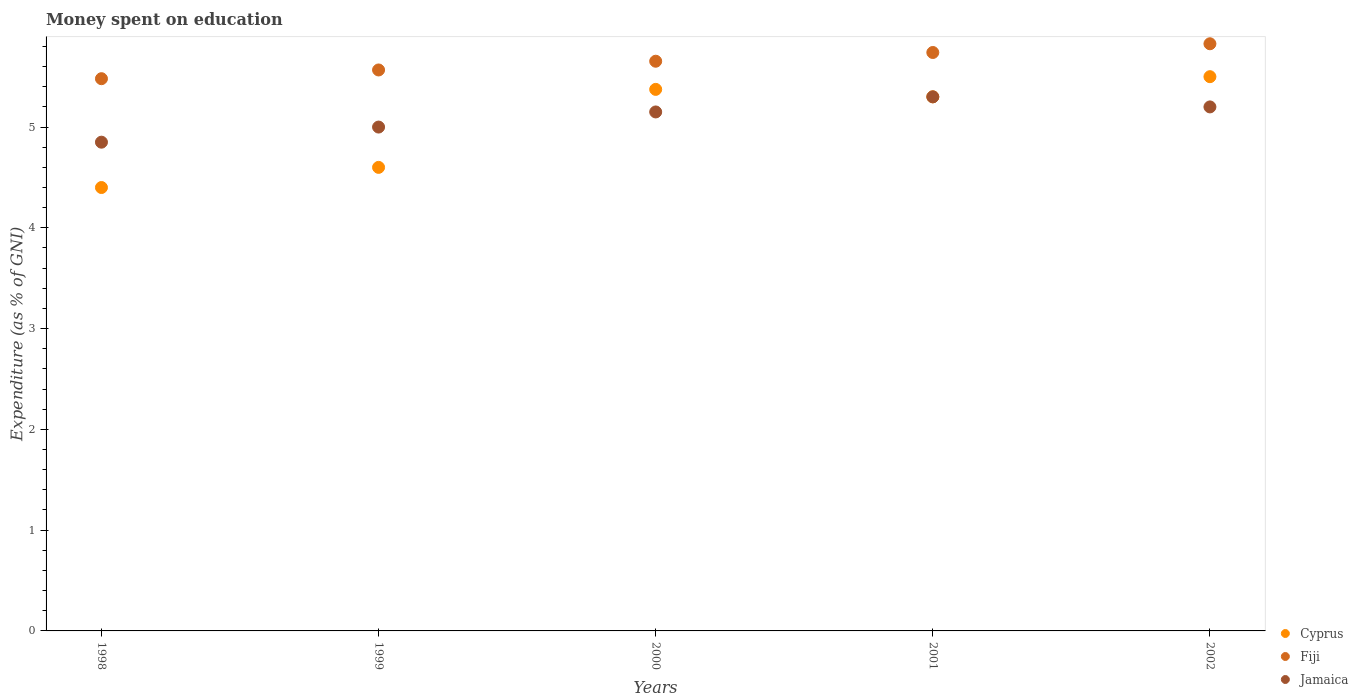Is the number of dotlines equal to the number of legend labels?
Your answer should be very brief. Yes. What is the amount of money spent on education in Fiji in 2002?
Make the answer very short. 5.83. Across all years, what is the maximum amount of money spent on education in Fiji?
Give a very brief answer. 5.83. Across all years, what is the minimum amount of money spent on education in Fiji?
Give a very brief answer. 5.48. In which year was the amount of money spent on education in Jamaica maximum?
Your answer should be compact. 2001. What is the total amount of money spent on education in Cyprus in the graph?
Offer a terse response. 25.17. What is the difference between the amount of money spent on education in Cyprus in 1998 and that in 2002?
Keep it short and to the point. -1.1. What is the difference between the amount of money spent on education in Cyprus in 1998 and the amount of money spent on education in Jamaica in 1999?
Offer a terse response. -0.6. What is the average amount of money spent on education in Fiji per year?
Your answer should be compact. 5.65. In the year 1999, what is the difference between the amount of money spent on education in Cyprus and amount of money spent on education in Fiji?
Your response must be concise. -0.97. In how many years, is the amount of money spent on education in Fiji greater than 1.6 %?
Ensure brevity in your answer.  5. What is the ratio of the amount of money spent on education in Cyprus in 1998 to that in 1999?
Keep it short and to the point. 0.96. Is the difference between the amount of money spent on education in Cyprus in 2001 and 2002 greater than the difference between the amount of money spent on education in Fiji in 2001 and 2002?
Provide a short and direct response. No. What is the difference between the highest and the second highest amount of money spent on education in Cyprus?
Provide a short and direct response. 0.13. What is the difference between the highest and the lowest amount of money spent on education in Fiji?
Ensure brevity in your answer.  0.35. In how many years, is the amount of money spent on education in Fiji greater than the average amount of money spent on education in Fiji taken over all years?
Offer a very short reply. 2. Is the sum of the amount of money spent on education in Cyprus in 1998 and 2001 greater than the maximum amount of money spent on education in Jamaica across all years?
Your response must be concise. Yes. Is the amount of money spent on education in Fiji strictly greater than the amount of money spent on education in Cyprus over the years?
Your response must be concise. Yes. Is the amount of money spent on education in Cyprus strictly less than the amount of money spent on education in Jamaica over the years?
Your answer should be compact. No. How many dotlines are there?
Your answer should be very brief. 3. How many years are there in the graph?
Offer a terse response. 5. Are the values on the major ticks of Y-axis written in scientific E-notation?
Ensure brevity in your answer.  No. Does the graph contain any zero values?
Ensure brevity in your answer.  No. Does the graph contain grids?
Keep it short and to the point. No. Where does the legend appear in the graph?
Make the answer very short. Bottom right. What is the title of the graph?
Offer a terse response. Money spent on education. What is the label or title of the X-axis?
Keep it short and to the point. Years. What is the label or title of the Y-axis?
Your answer should be compact. Expenditure (as % of GNI). What is the Expenditure (as % of GNI) in Cyprus in 1998?
Keep it short and to the point. 4.4. What is the Expenditure (as % of GNI) of Fiji in 1998?
Your response must be concise. 5.48. What is the Expenditure (as % of GNI) of Jamaica in 1998?
Ensure brevity in your answer.  4.85. What is the Expenditure (as % of GNI) in Fiji in 1999?
Your answer should be compact. 5.57. What is the Expenditure (as % of GNI) of Jamaica in 1999?
Offer a terse response. 5. What is the Expenditure (as % of GNI) in Cyprus in 2000?
Ensure brevity in your answer.  5.37. What is the Expenditure (as % of GNI) in Fiji in 2000?
Give a very brief answer. 5.65. What is the Expenditure (as % of GNI) of Jamaica in 2000?
Your answer should be very brief. 5.15. What is the Expenditure (as % of GNI) in Fiji in 2001?
Provide a short and direct response. 5.74. What is the Expenditure (as % of GNI) in Jamaica in 2001?
Ensure brevity in your answer.  5.3. What is the Expenditure (as % of GNI) of Cyprus in 2002?
Provide a succinct answer. 5.5. What is the Expenditure (as % of GNI) in Fiji in 2002?
Offer a very short reply. 5.83. Across all years, what is the maximum Expenditure (as % of GNI) of Cyprus?
Provide a short and direct response. 5.5. Across all years, what is the maximum Expenditure (as % of GNI) of Fiji?
Your answer should be compact. 5.83. Across all years, what is the maximum Expenditure (as % of GNI) of Jamaica?
Offer a very short reply. 5.3. Across all years, what is the minimum Expenditure (as % of GNI) of Cyprus?
Make the answer very short. 4.4. Across all years, what is the minimum Expenditure (as % of GNI) in Fiji?
Make the answer very short. 5.48. Across all years, what is the minimum Expenditure (as % of GNI) in Jamaica?
Ensure brevity in your answer.  4.85. What is the total Expenditure (as % of GNI) in Cyprus in the graph?
Make the answer very short. 25.17. What is the total Expenditure (as % of GNI) of Fiji in the graph?
Your answer should be very brief. 28.27. What is the total Expenditure (as % of GNI) of Jamaica in the graph?
Your answer should be very brief. 25.5. What is the difference between the Expenditure (as % of GNI) of Fiji in 1998 and that in 1999?
Ensure brevity in your answer.  -0.09. What is the difference between the Expenditure (as % of GNI) of Jamaica in 1998 and that in 1999?
Provide a short and direct response. -0.15. What is the difference between the Expenditure (as % of GNI) of Cyprus in 1998 and that in 2000?
Give a very brief answer. -0.97. What is the difference between the Expenditure (as % of GNI) of Fiji in 1998 and that in 2000?
Ensure brevity in your answer.  -0.17. What is the difference between the Expenditure (as % of GNI) in Jamaica in 1998 and that in 2000?
Provide a short and direct response. -0.3. What is the difference between the Expenditure (as % of GNI) in Fiji in 1998 and that in 2001?
Offer a terse response. -0.26. What is the difference between the Expenditure (as % of GNI) in Jamaica in 1998 and that in 2001?
Make the answer very short. -0.45. What is the difference between the Expenditure (as % of GNI) of Fiji in 1998 and that in 2002?
Your response must be concise. -0.35. What is the difference between the Expenditure (as % of GNI) in Jamaica in 1998 and that in 2002?
Give a very brief answer. -0.35. What is the difference between the Expenditure (as % of GNI) in Cyprus in 1999 and that in 2000?
Offer a terse response. -0.77. What is the difference between the Expenditure (as % of GNI) in Fiji in 1999 and that in 2000?
Ensure brevity in your answer.  -0.09. What is the difference between the Expenditure (as % of GNI) of Jamaica in 1999 and that in 2000?
Ensure brevity in your answer.  -0.15. What is the difference between the Expenditure (as % of GNI) in Fiji in 1999 and that in 2001?
Keep it short and to the point. -0.17. What is the difference between the Expenditure (as % of GNI) of Jamaica in 1999 and that in 2001?
Provide a succinct answer. -0.3. What is the difference between the Expenditure (as % of GNI) in Fiji in 1999 and that in 2002?
Offer a very short reply. -0.26. What is the difference between the Expenditure (as % of GNI) in Cyprus in 2000 and that in 2001?
Your answer should be compact. 0.07. What is the difference between the Expenditure (as % of GNI) in Fiji in 2000 and that in 2001?
Your answer should be very brief. -0.09. What is the difference between the Expenditure (as % of GNI) in Cyprus in 2000 and that in 2002?
Offer a very short reply. -0.13. What is the difference between the Expenditure (as % of GNI) in Fiji in 2000 and that in 2002?
Offer a very short reply. -0.17. What is the difference between the Expenditure (as % of GNI) of Jamaica in 2000 and that in 2002?
Provide a short and direct response. -0.05. What is the difference between the Expenditure (as % of GNI) of Fiji in 2001 and that in 2002?
Provide a succinct answer. -0.09. What is the difference between the Expenditure (as % of GNI) of Cyprus in 1998 and the Expenditure (as % of GNI) of Fiji in 1999?
Make the answer very short. -1.17. What is the difference between the Expenditure (as % of GNI) in Fiji in 1998 and the Expenditure (as % of GNI) in Jamaica in 1999?
Your answer should be very brief. 0.48. What is the difference between the Expenditure (as % of GNI) of Cyprus in 1998 and the Expenditure (as % of GNI) of Fiji in 2000?
Offer a terse response. -1.25. What is the difference between the Expenditure (as % of GNI) of Cyprus in 1998 and the Expenditure (as % of GNI) of Jamaica in 2000?
Your answer should be very brief. -0.75. What is the difference between the Expenditure (as % of GNI) of Fiji in 1998 and the Expenditure (as % of GNI) of Jamaica in 2000?
Your answer should be compact. 0.33. What is the difference between the Expenditure (as % of GNI) in Cyprus in 1998 and the Expenditure (as % of GNI) in Fiji in 2001?
Offer a terse response. -1.34. What is the difference between the Expenditure (as % of GNI) of Fiji in 1998 and the Expenditure (as % of GNI) of Jamaica in 2001?
Provide a succinct answer. 0.18. What is the difference between the Expenditure (as % of GNI) of Cyprus in 1998 and the Expenditure (as % of GNI) of Fiji in 2002?
Your answer should be compact. -1.43. What is the difference between the Expenditure (as % of GNI) in Fiji in 1998 and the Expenditure (as % of GNI) in Jamaica in 2002?
Offer a terse response. 0.28. What is the difference between the Expenditure (as % of GNI) of Cyprus in 1999 and the Expenditure (as % of GNI) of Fiji in 2000?
Offer a terse response. -1.05. What is the difference between the Expenditure (as % of GNI) of Cyprus in 1999 and the Expenditure (as % of GNI) of Jamaica in 2000?
Provide a succinct answer. -0.55. What is the difference between the Expenditure (as % of GNI) in Fiji in 1999 and the Expenditure (as % of GNI) in Jamaica in 2000?
Offer a very short reply. 0.42. What is the difference between the Expenditure (as % of GNI) in Cyprus in 1999 and the Expenditure (as % of GNI) in Fiji in 2001?
Your response must be concise. -1.14. What is the difference between the Expenditure (as % of GNI) in Cyprus in 1999 and the Expenditure (as % of GNI) in Jamaica in 2001?
Give a very brief answer. -0.7. What is the difference between the Expenditure (as % of GNI) of Fiji in 1999 and the Expenditure (as % of GNI) of Jamaica in 2001?
Give a very brief answer. 0.27. What is the difference between the Expenditure (as % of GNI) of Cyprus in 1999 and the Expenditure (as % of GNI) of Fiji in 2002?
Your answer should be compact. -1.23. What is the difference between the Expenditure (as % of GNI) of Fiji in 1999 and the Expenditure (as % of GNI) of Jamaica in 2002?
Keep it short and to the point. 0.37. What is the difference between the Expenditure (as % of GNI) in Cyprus in 2000 and the Expenditure (as % of GNI) in Fiji in 2001?
Provide a succinct answer. -0.37. What is the difference between the Expenditure (as % of GNI) in Cyprus in 2000 and the Expenditure (as % of GNI) in Jamaica in 2001?
Provide a succinct answer. 0.07. What is the difference between the Expenditure (as % of GNI) in Fiji in 2000 and the Expenditure (as % of GNI) in Jamaica in 2001?
Offer a terse response. 0.35. What is the difference between the Expenditure (as % of GNI) in Cyprus in 2000 and the Expenditure (as % of GNI) in Fiji in 2002?
Provide a succinct answer. -0.45. What is the difference between the Expenditure (as % of GNI) in Cyprus in 2000 and the Expenditure (as % of GNI) in Jamaica in 2002?
Ensure brevity in your answer.  0.17. What is the difference between the Expenditure (as % of GNI) in Fiji in 2000 and the Expenditure (as % of GNI) in Jamaica in 2002?
Offer a very short reply. 0.45. What is the difference between the Expenditure (as % of GNI) in Cyprus in 2001 and the Expenditure (as % of GNI) in Fiji in 2002?
Offer a very short reply. -0.53. What is the difference between the Expenditure (as % of GNI) of Fiji in 2001 and the Expenditure (as % of GNI) of Jamaica in 2002?
Your response must be concise. 0.54. What is the average Expenditure (as % of GNI) in Cyprus per year?
Your response must be concise. 5.03. What is the average Expenditure (as % of GNI) of Fiji per year?
Offer a very short reply. 5.65. In the year 1998, what is the difference between the Expenditure (as % of GNI) in Cyprus and Expenditure (as % of GNI) in Fiji?
Your answer should be very brief. -1.08. In the year 1998, what is the difference between the Expenditure (as % of GNI) of Cyprus and Expenditure (as % of GNI) of Jamaica?
Provide a succinct answer. -0.45. In the year 1998, what is the difference between the Expenditure (as % of GNI) of Fiji and Expenditure (as % of GNI) of Jamaica?
Your answer should be compact. 0.63. In the year 1999, what is the difference between the Expenditure (as % of GNI) in Cyprus and Expenditure (as % of GNI) in Fiji?
Your answer should be very brief. -0.97. In the year 1999, what is the difference between the Expenditure (as % of GNI) of Fiji and Expenditure (as % of GNI) of Jamaica?
Your answer should be very brief. 0.57. In the year 2000, what is the difference between the Expenditure (as % of GNI) in Cyprus and Expenditure (as % of GNI) in Fiji?
Keep it short and to the point. -0.28. In the year 2000, what is the difference between the Expenditure (as % of GNI) of Cyprus and Expenditure (as % of GNI) of Jamaica?
Make the answer very short. 0.22. In the year 2000, what is the difference between the Expenditure (as % of GNI) of Fiji and Expenditure (as % of GNI) of Jamaica?
Give a very brief answer. 0.5. In the year 2001, what is the difference between the Expenditure (as % of GNI) of Cyprus and Expenditure (as % of GNI) of Fiji?
Provide a succinct answer. -0.44. In the year 2001, what is the difference between the Expenditure (as % of GNI) of Fiji and Expenditure (as % of GNI) of Jamaica?
Ensure brevity in your answer.  0.44. In the year 2002, what is the difference between the Expenditure (as % of GNI) in Cyprus and Expenditure (as % of GNI) in Fiji?
Your answer should be very brief. -0.33. In the year 2002, what is the difference between the Expenditure (as % of GNI) in Fiji and Expenditure (as % of GNI) in Jamaica?
Offer a very short reply. 0.63. What is the ratio of the Expenditure (as % of GNI) in Cyprus in 1998 to that in 1999?
Offer a terse response. 0.96. What is the ratio of the Expenditure (as % of GNI) of Fiji in 1998 to that in 1999?
Make the answer very short. 0.98. What is the ratio of the Expenditure (as % of GNI) in Cyprus in 1998 to that in 2000?
Provide a succinct answer. 0.82. What is the ratio of the Expenditure (as % of GNI) in Fiji in 1998 to that in 2000?
Keep it short and to the point. 0.97. What is the ratio of the Expenditure (as % of GNI) in Jamaica in 1998 to that in 2000?
Provide a succinct answer. 0.94. What is the ratio of the Expenditure (as % of GNI) in Cyprus in 1998 to that in 2001?
Provide a short and direct response. 0.83. What is the ratio of the Expenditure (as % of GNI) in Fiji in 1998 to that in 2001?
Give a very brief answer. 0.95. What is the ratio of the Expenditure (as % of GNI) in Jamaica in 1998 to that in 2001?
Your answer should be very brief. 0.92. What is the ratio of the Expenditure (as % of GNI) in Fiji in 1998 to that in 2002?
Provide a succinct answer. 0.94. What is the ratio of the Expenditure (as % of GNI) in Jamaica in 1998 to that in 2002?
Offer a terse response. 0.93. What is the ratio of the Expenditure (as % of GNI) of Cyprus in 1999 to that in 2000?
Make the answer very short. 0.86. What is the ratio of the Expenditure (as % of GNI) in Fiji in 1999 to that in 2000?
Provide a succinct answer. 0.98. What is the ratio of the Expenditure (as % of GNI) of Jamaica in 1999 to that in 2000?
Ensure brevity in your answer.  0.97. What is the ratio of the Expenditure (as % of GNI) in Cyprus in 1999 to that in 2001?
Offer a very short reply. 0.87. What is the ratio of the Expenditure (as % of GNI) in Fiji in 1999 to that in 2001?
Keep it short and to the point. 0.97. What is the ratio of the Expenditure (as % of GNI) in Jamaica in 1999 to that in 2001?
Your answer should be compact. 0.94. What is the ratio of the Expenditure (as % of GNI) of Cyprus in 1999 to that in 2002?
Ensure brevity in your answer.  0.84. What is the ratio of the Expenditure (as % of GNI) of Fiji in 1999 to that in 2002?
Provide a short and direct response. 0.96. What is the ratio of the Expenditure (as % of GNI) of Jamaica in 1999 to that in 2002?
Give a very brief answer. 0.96. What is the ratio of the Expenditure (as % of GNI) in Fiji in 2000 to that in 2001?
Ensure brevity in your answer.  0.98. What is the ratio of the Expenditure (as % of GNI) of Jamaica in 2000 to that in 2001?
Ensure brevity in your answer.  0.97. What is the ratio of the Expenditure (as % of GNI) in Cyprus in 2000 to that in 2002?
Ensure brevity in your answer.  0.98. What is the ratio of the Expenditure (as % of GNI) of Fiji in 2000 to that in 2002?
Your response must be concise. 0.97. What is the ratio of the Expenditure (as % of GNI) in Jamaica in 2000 to that in 2002?
Your answer should be very brief. 0.99. What is the ratio of the Expenditure (as % of GNI) in Cyprus in 2001 to that in 2002?
Provide a succinct answer. 0.96. What is the ratio of the Expenditure (as % of GNI) in Fiji in 2001 to that in 2002?
Offer a very short reply. 0.99. What is the ratio of the Expenditure (as % of GNI) in Jamaica in 2001 to that in 2002?
Your response must be concise. 1.02. What is the difference between the highest and the second highest Expenditure (as % of GNI) in Cyprus?
Your response must be concise. 0.13. What is the difference between the highest and the second highest Expenditure (as % of GNI) of Fiji?
Your answer should be compact. 0.09. What is the difference between the highest and the second highest Expenditure (as % of GNI) in Jamaica?
Make the answer very short. 0.1. What is the difference between the highest and the lowest Expenditure (as % of GNI) in Fiji?
Offer a terse response. 0.35. What is the difference between the highest and the lowest Expenditure (as % of GNI) in Jamaica?
Your response must be concise. 0.45. 